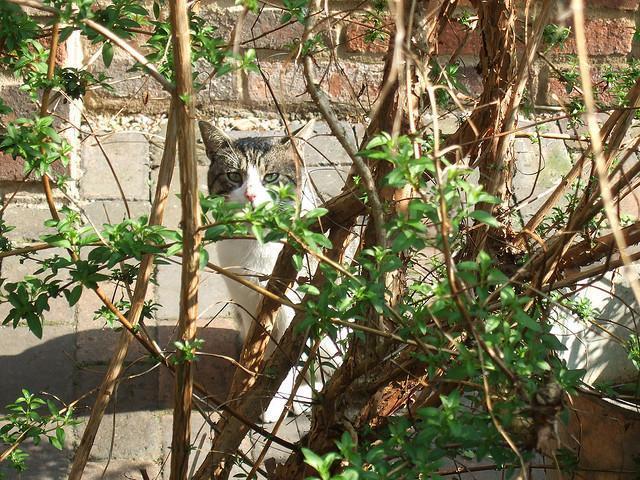How many cats are visible?
Give a very brief answer. 1. How many people in the picture?
Give a very brief answer. 0. 